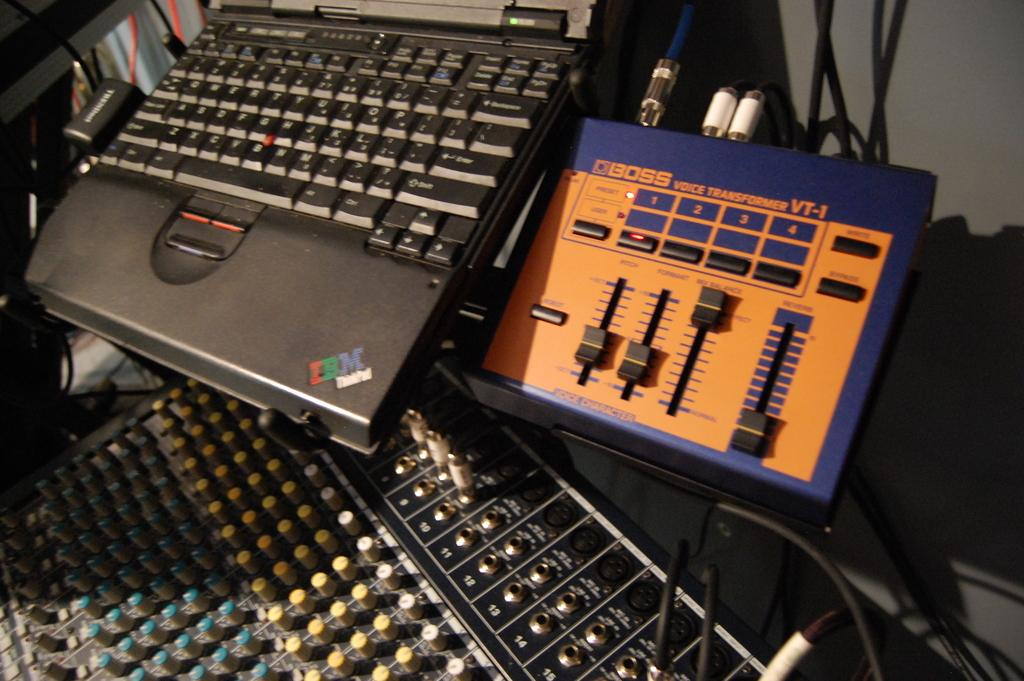What electronic device is visible in the image? There is a laptop in the image. What is the color of the laptop? The laptop is black in color. Is there any branding or logo on the laptop? Yes, there is a logo on the laptop. What else can be seen in the image besides the laptop? There are wires and other electronic machines visible in the image. What type of seed is being planted on the roof in the image? There is no seed or roof present in the image; it features a laptop and other electronic machines. 